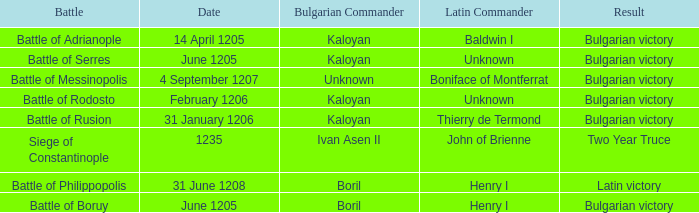Can you parse all the data within this table? {'header': ['Battle', 'Date', 'Bulgarian Commander', 'Latin Commander', 'Result'], 'rows': [['Battle of Adrianople', '14 April 1205', 'Kaloyan', 'Baldwin I', 'Bulgarian victory'], ['Battle of Serres', 'June 1205', 'Kaloyan', 'Unknown', 'Bulgarian victory'], ['Battle of Messinopolis', '4 September 1207', 'Unknown', 'Boniface of Montferrat', 'Bulgarian victory'], ['Battle of Rodosto', 'February 1206', 'Kaloyan', 'Unknown', 'Bulgarian victory'], ['Battle of Rusion', '31 January 1206', 'Kaloyan', 'Thierry de Termond', 'Bulgarian victory'], ['Siege of Constantinople', '1235', 'Ivan Asen II', 'John of Brienne', 'Two Year Truce'], ['Battle of Philippopolis', '31 June 1208', 'Boril', 'Henry I', 'Latin victory'], ['Battle of Boruy', 'June 1205', 'Boril', 'Henry I', 'Bulgarian victory']]} Who is the Latin Commander of the Siege of Constantinople? John of Brienne. 